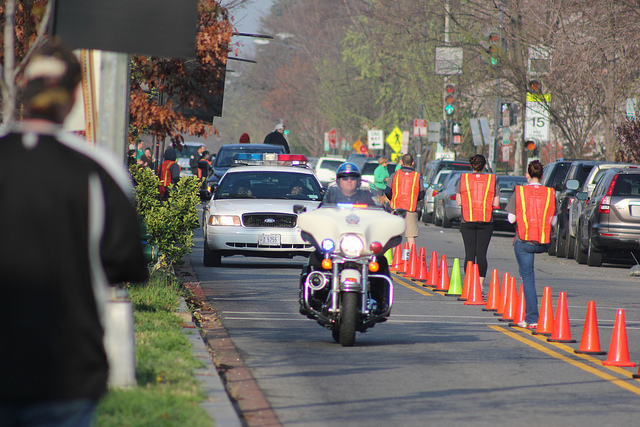Please transcribe the text information in this image. 15 